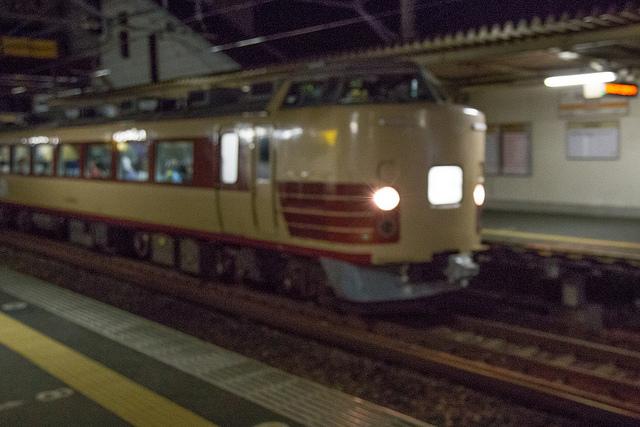What vehicle is shown?
Be succinct. Train. Is the vehicle on a track?
Short answer required. Yes. Is there graffiti on the train?
Answer briefly. No. Is the trains headlight on?
Be succinct. Yes. 